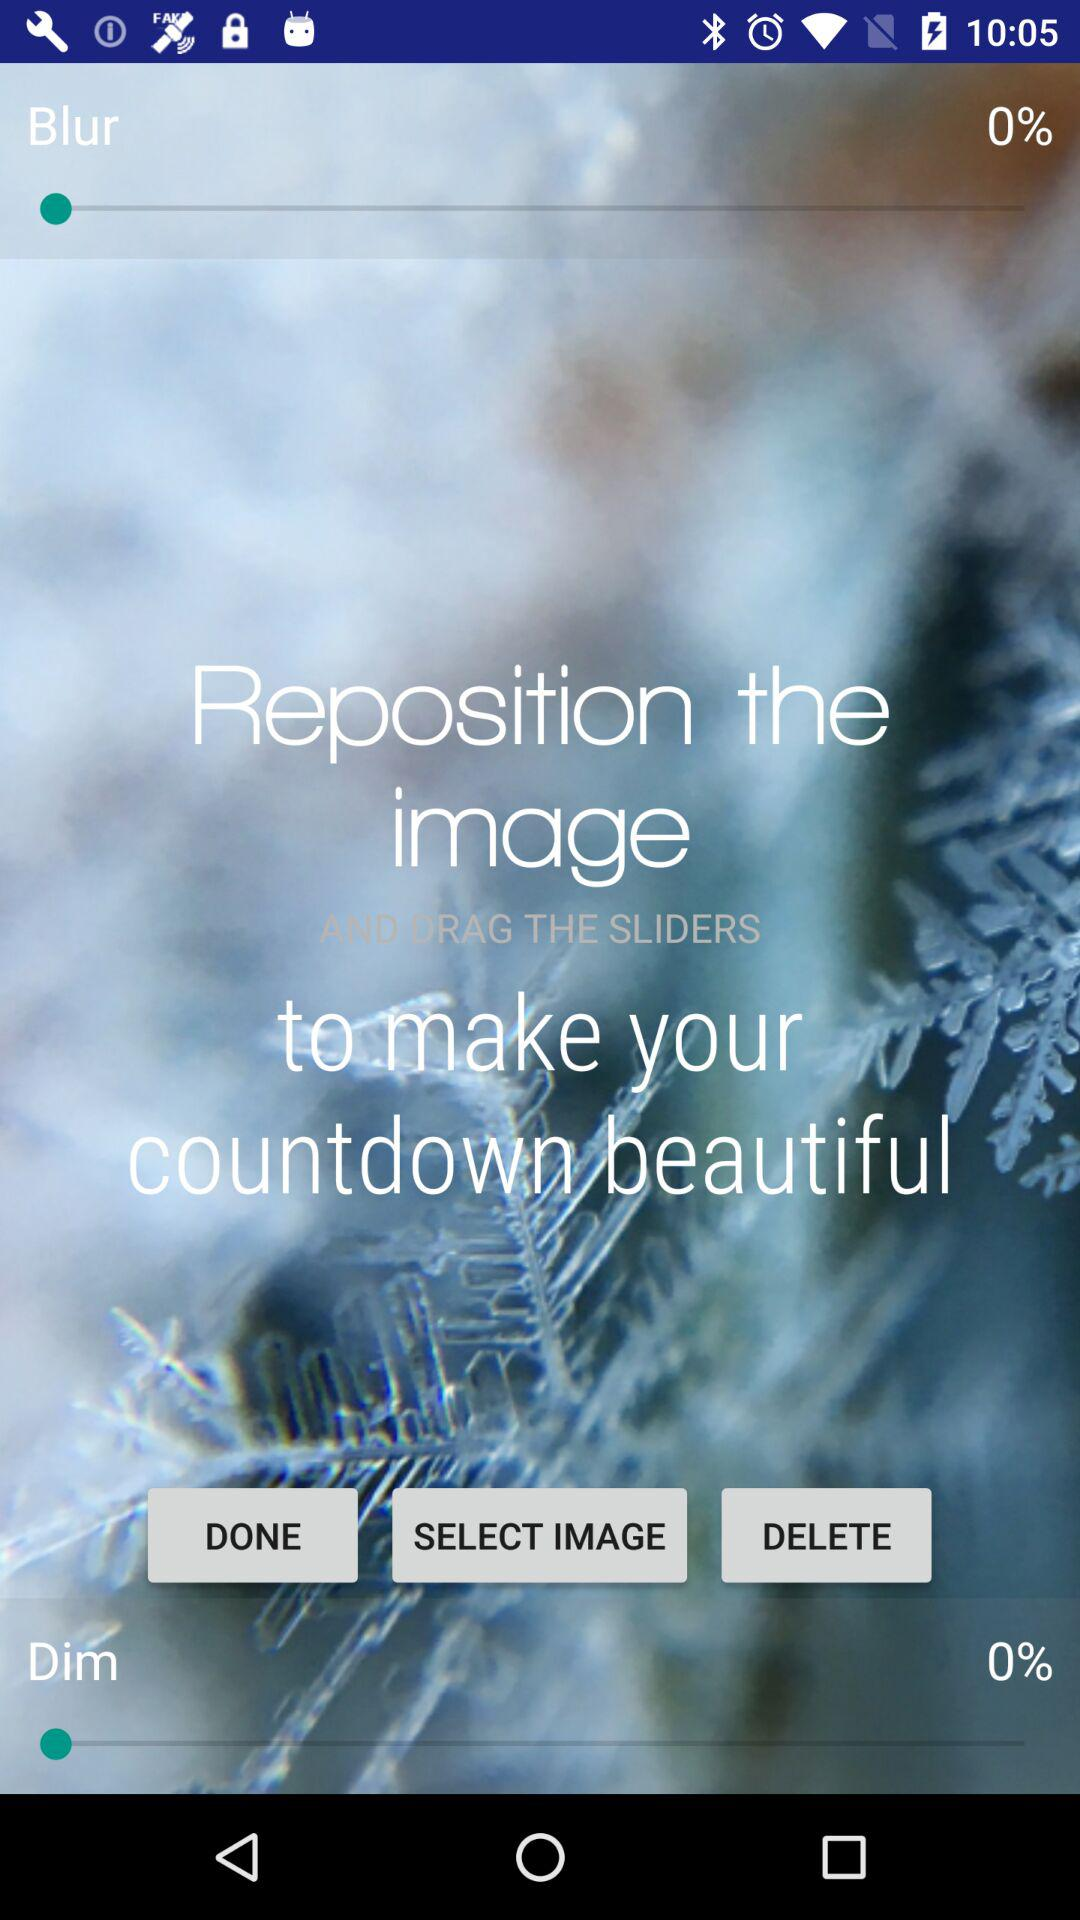What's the blur percentage? The blur percentage is 0. 